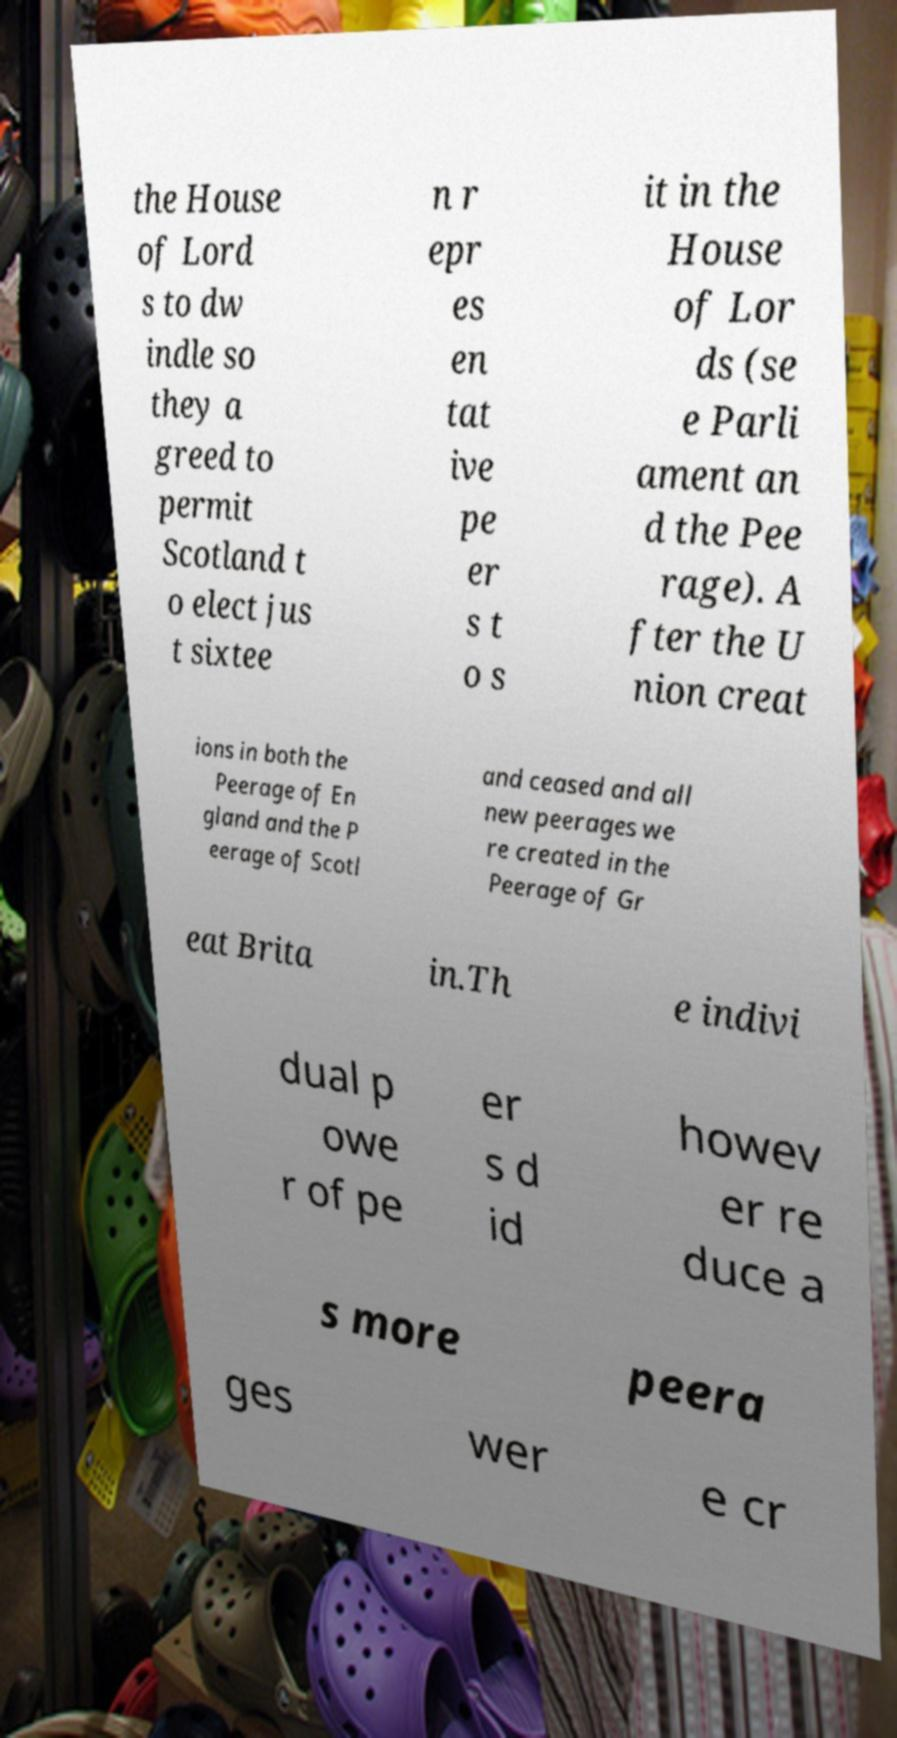Could you extract and type out the text from this image? the House of Lord s to dw indle so they a greed to permit Scotland t o elect jus t sixtee n r epr es en tat ive pe er s t o s it in the House of Lor ds (se e Parli ament an d the Pee rage). A fter the U nion creat ions in both the Peerage of En gland and the P eerage of Scotl and ceased and all new peerages we re created in the Peerage of Gr eat Brita in.Th e indivi dual p owe r of pe er s d id howev er re duce a s more peera ges wer e cr 